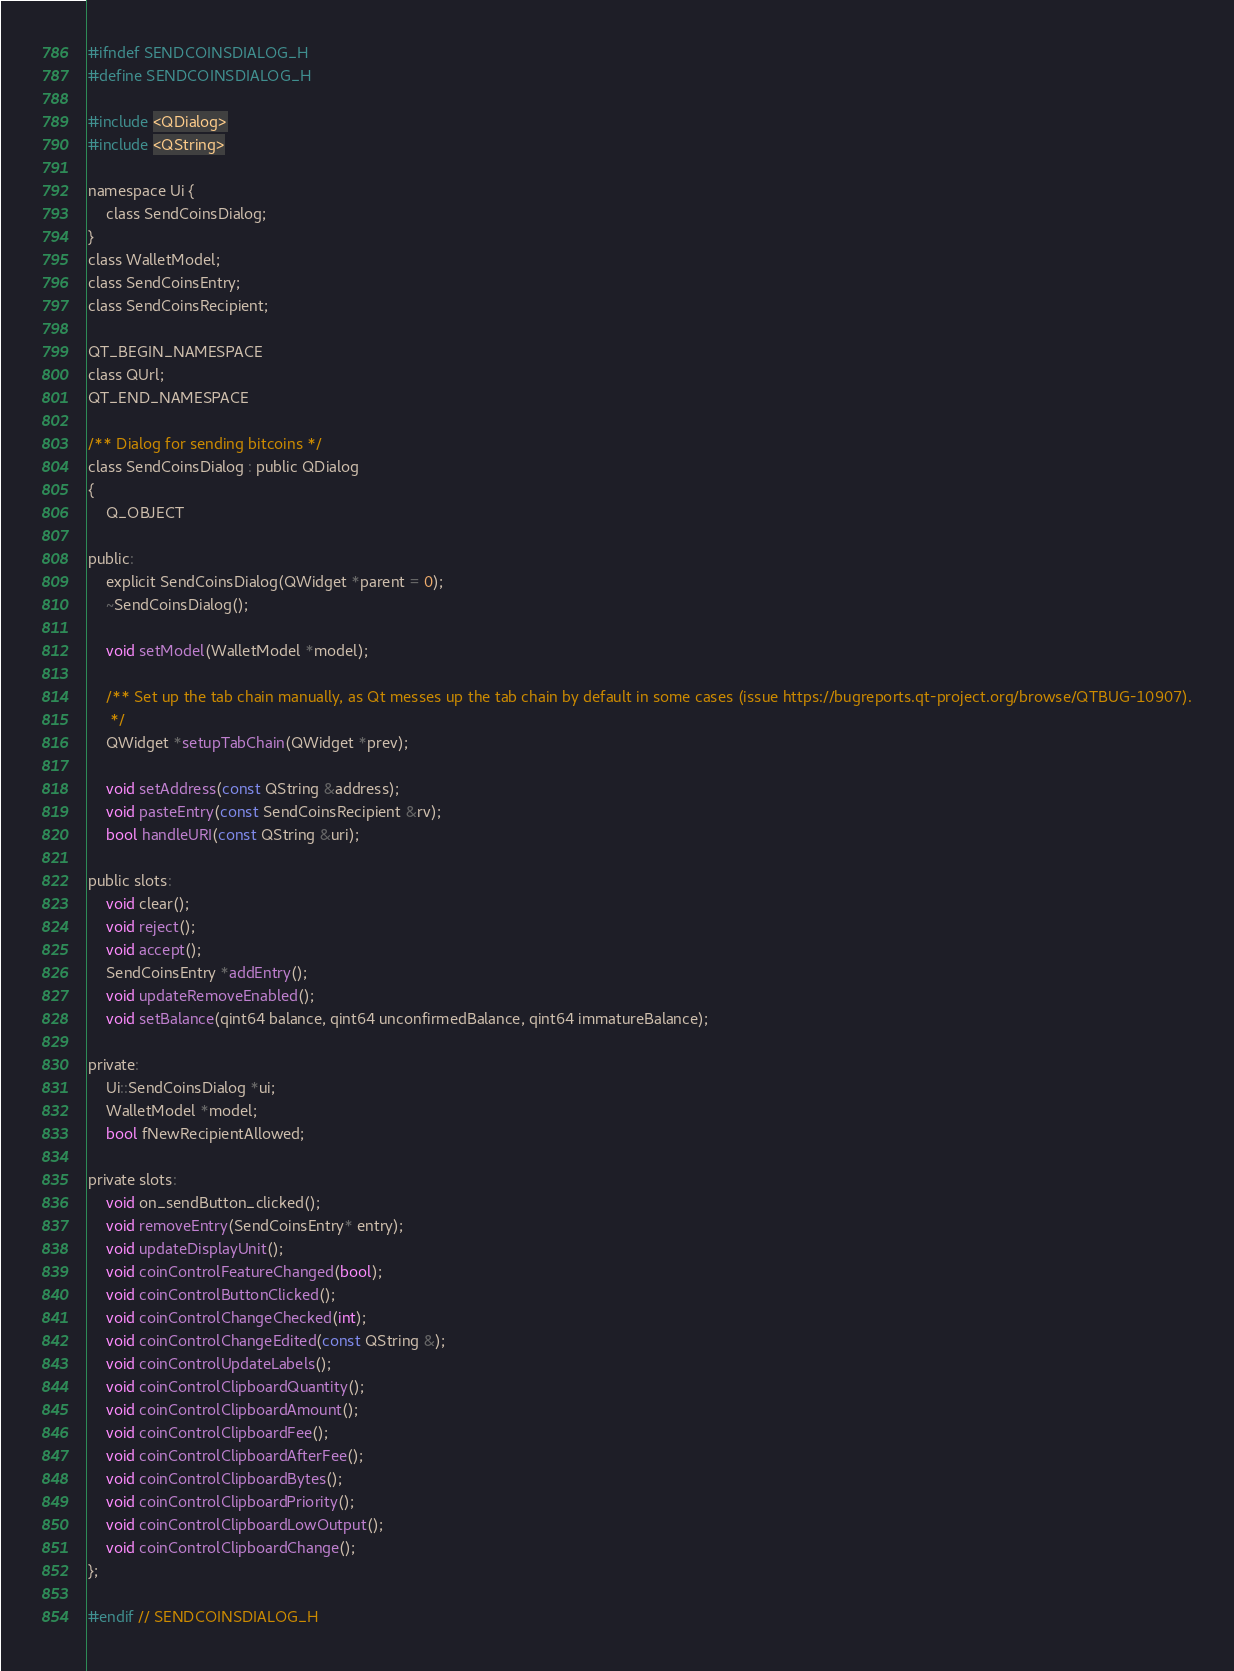<code> <loc_0><loc_0><loc_500><loc_500><_C_>#ifndef SENDCOINSDIALOG_H
#define SENDCOINSDIALOG_H

#include <QDialog>
#include <QString>

namespace Ui {
    class SendCoinsDialog;
}
class WalletModel;
class SendCoinsEntry;
class SendCoinsRecipient;

QT_BEGIN_NAMESPACE
class QUrl;
QT_END_NAMESPACE

/** Dialog for sending bitcoins */
class SendCoinsDialog : public QDialog
{
    Q_OBJECT

public:
    explicit SendCoinsDialog(QWidget *parent = 0);
    ~SendCoinsDialog();

    void setModel(WalletModel *model);

    /** Set up the tab chain manually, as Qt messes up the tab chain by default in some cases (issue https://bugreports.qt-project.org/browse/QTBUG-10907).
     */
    QWidget *setupTabChain(QWidget *prev);

    void setAddress(const QString &address);
    void pasteEntry(const SendCoinsRecipient &rv);
    bool handleURI(const QString &uri);

public slots:
    void clear();
    void reject();
    void accept();
    SendCoinsEntry *addEntry();
    void updateRemoveEnabled();
    void setBalance(qint64 balance, qint64 unconfirmedBalance, qint64 immatureBalance);

private:
    Ui::SendCoinsDialog *ui;
    WalletModel *model;
    bool fNewRecipientAllowed;

private slots:
    void on_sendButton_clicked();
    void removeEntry(SendCoinsEntry* entry);
    void updateDisplayUnit();
    void coinControlFeatureChanged(bool);
    void coinControlButtonClicked();
    void coinControlChangeChecked(int);
    void coinControlChangeEdited(const QString &);
    void coinControlUpdateLabels();
    void coinControlClipboardQuantity();
    void coinControlClipboardAmount();
    void coinControlClipboardFee();
    void coinControlClipboardAfterFee();
    void coinControlClipboardBytes();
    void coinControlClipboardPriority();
    void coinControlClipboardLowOutput();
    void coinControlClipboardChange();
};

#endif // SENDCOINSDIALOG_H
</code> 